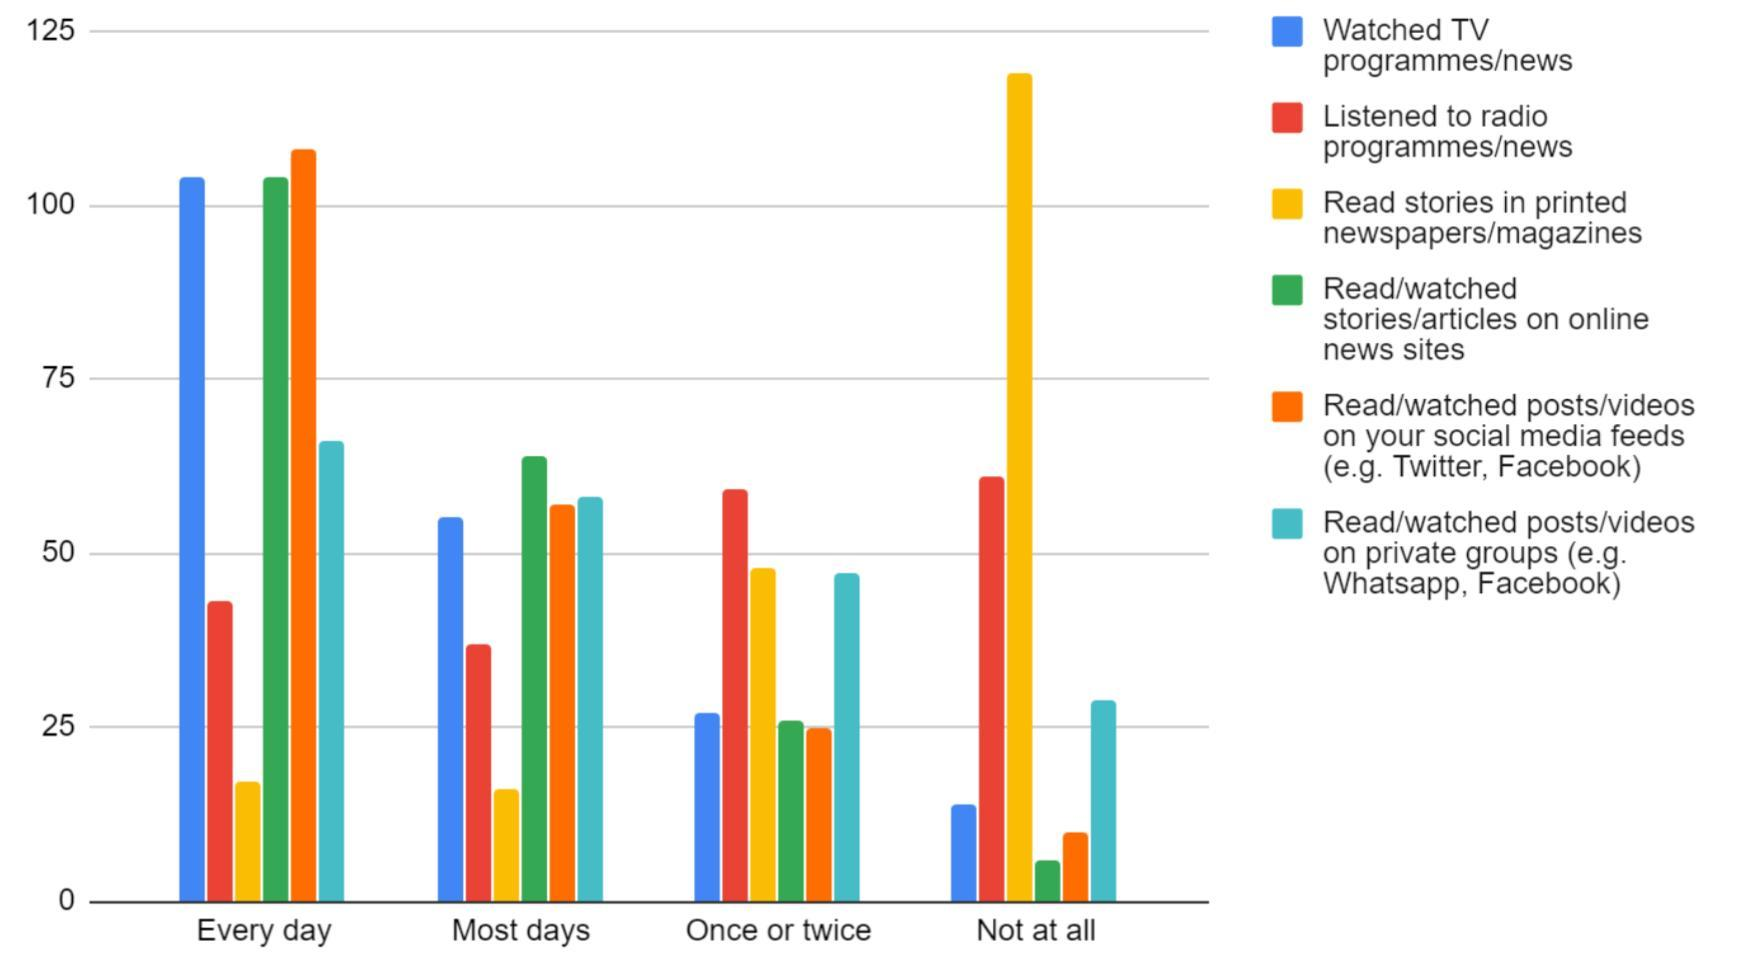Which color is used to represent "Listened to radio programs/news"-yellow, green, red, blue?
Answer the question with a short phrase. red Which color is used to represent "watched posts"-yellow, orange, red, blue? orange 